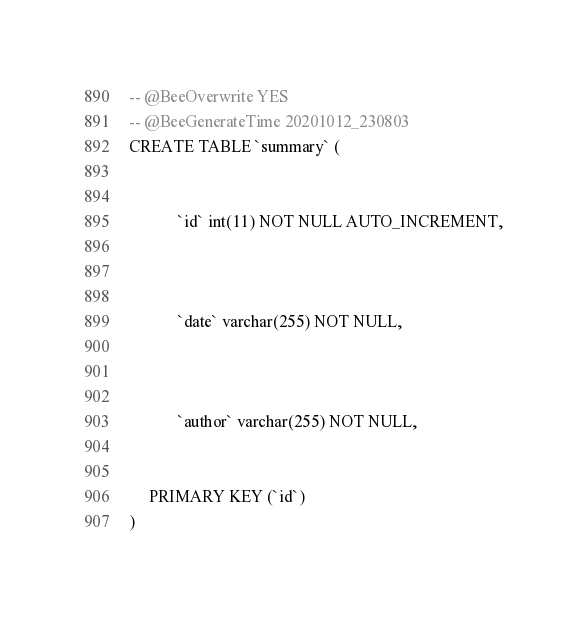<code> <loc_0><loc_0><loc_500><loc_500><_SQL_>-- @BeeOverwrite YES
-- @BeeGenerateTime 20201012_230803
CREATE TABLE `summary` (
     
        
            `id` int(11) NOT NULL AUTO_INCREMENT,
        
     
        
            `date` varchar(255) NOT NULL,
        
     
        
            `author` varchar(255) NOT NULL,
        
     
     PRIMARY KEY (`id`)
)
</code> 